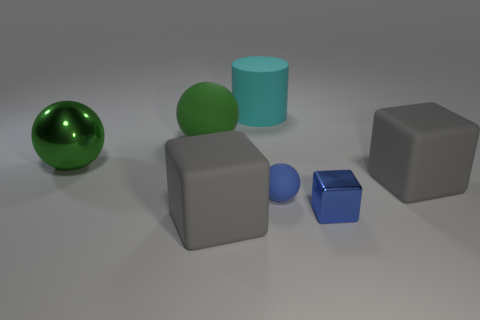Subtract all tiny blue blocks. How many blocks are left? 2 Add 2 large purple metallic blocks. How many objects exist? 9 Subtract 1 cylinders. How many cylinders are left? 0 Subtract all blue blocks. How many blocks are left? 2 Subtract all cylinders. How many objects are left? 6 Subtract all green cylinders. Subtract all gray balls. How many cylinders are left? 1 Subtract all blue cylinders. How many purple spheres are left? 0 Subtract all tiny blue things. Subtract all big cubes. How many objects are left? 3 Add 3 big cubes. How many big cubes are left? 5 Add 3 big brown blocks. How many big brown blocks exist? 3 